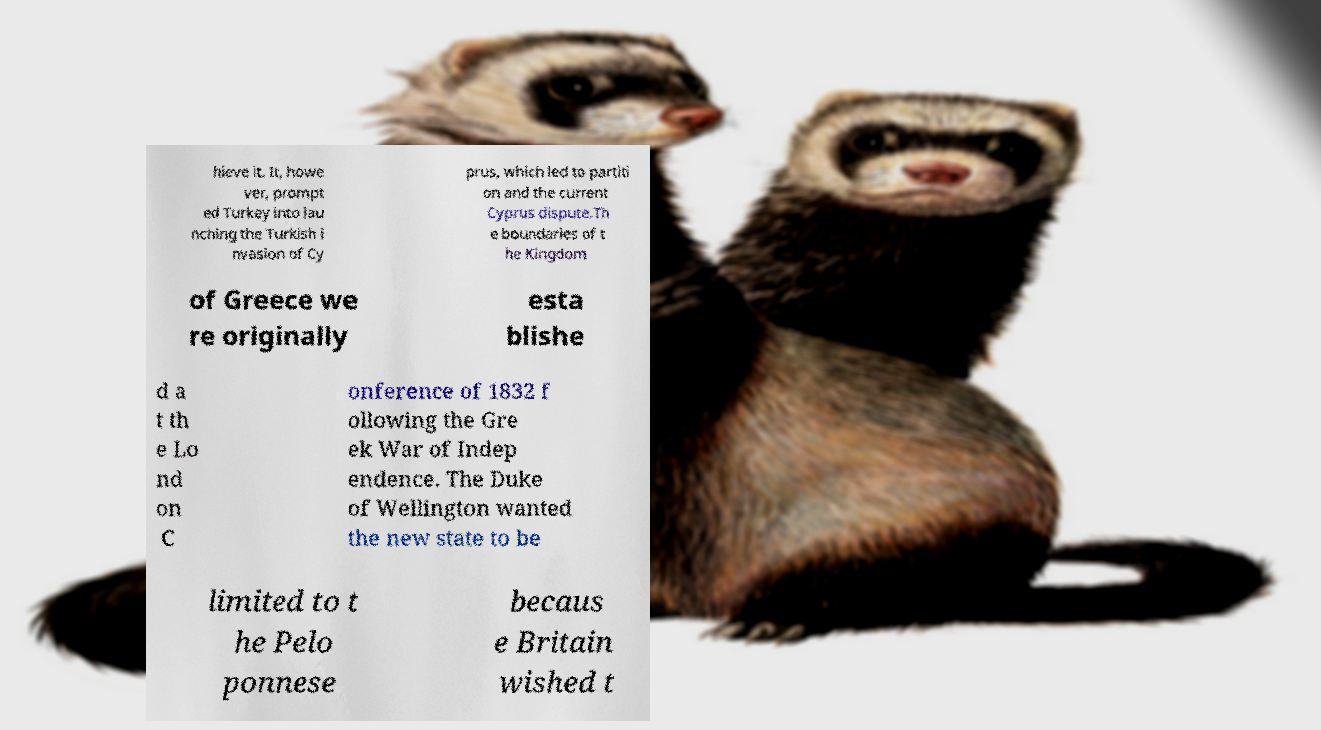Could you assist in decoding the text presented in this image and type it out clearly? hieve it. It, howe ver, prompt ed Turkey into lau nching the Turkish i nvasion of Cy prus, which led to partiti on and the current Cyprus dispute.Th e boundaries of t he Kingdom of Greece we re originally esta blishe d a t th e Lo nd on C onference of 1832 f ollowing the Gre ek War of Indep endence. The Duke of Wellington wanted the new state to be limited to t he Pelo ponnese becaus e Britain wished t 